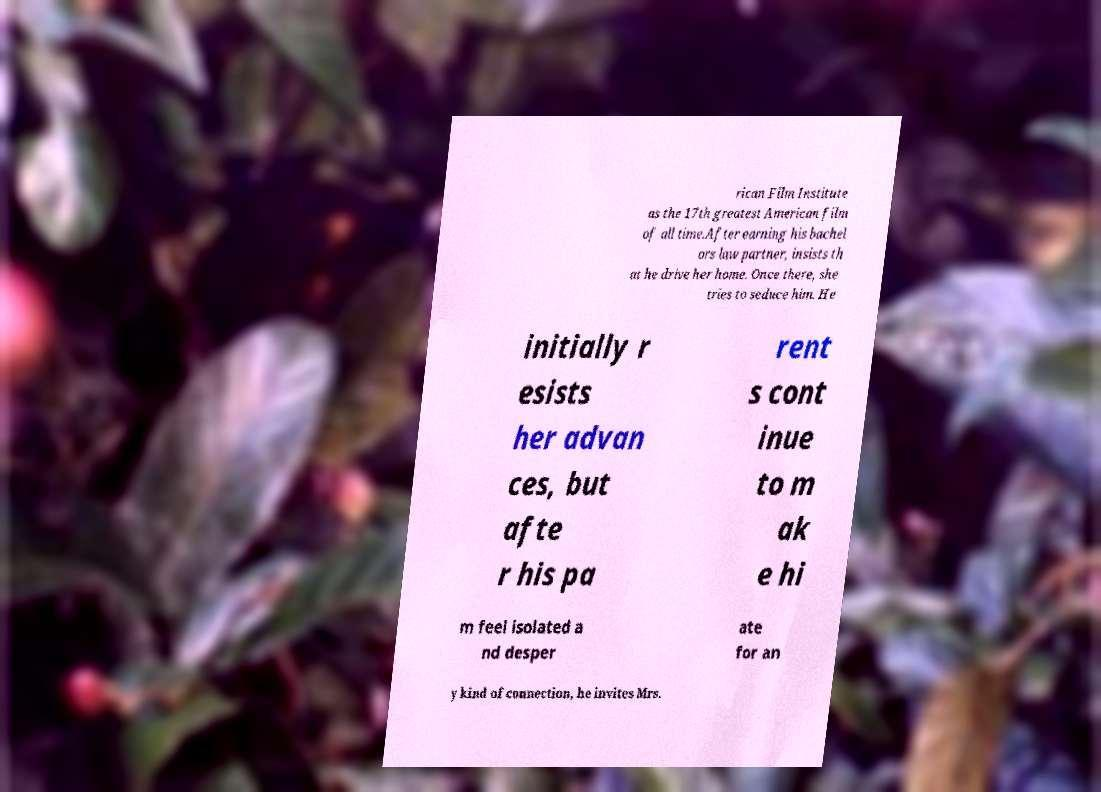Could you extract and type out the text from this image? rican Film Institute as the 17th greatest American film of all time.After earning his bachel ors law partner, insists th at he drive her home. Once there, she tries to seduce him. He initially r esists her advan ces, but afte r his pa rent s cont inue to m ak e hi m feel isolated a nd desper ate for an y kind of connection, he invites Mrs. 